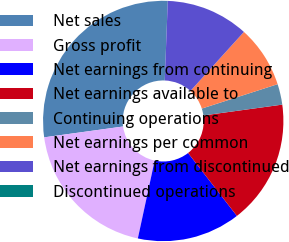Convert chart to OTSL. <chart><loc_0><loc_0><loc_500><loc_500><pie_chart><fcel>Net sales<fcel>Gross profit<fcel>Net earnings from continuing<fcel>Net earnings available to<fcel>Continuing operations<fcel>Net earnings per common<fcel>Net earnings from discontinued<fcel>Discontinued operations<nl><fcel>27.78%<fcel>19.44%<fcel>13.89%<fcel>16.67%<fcel>2.78%<fcel>8.33%<fcel>11.11%<fcel>0.0%<nl></chart> 